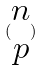<formula> <loc_0><loc_0><loc_500><loc_500>( \begin{matrix} n \\ p \end{matrix} )</formula> 